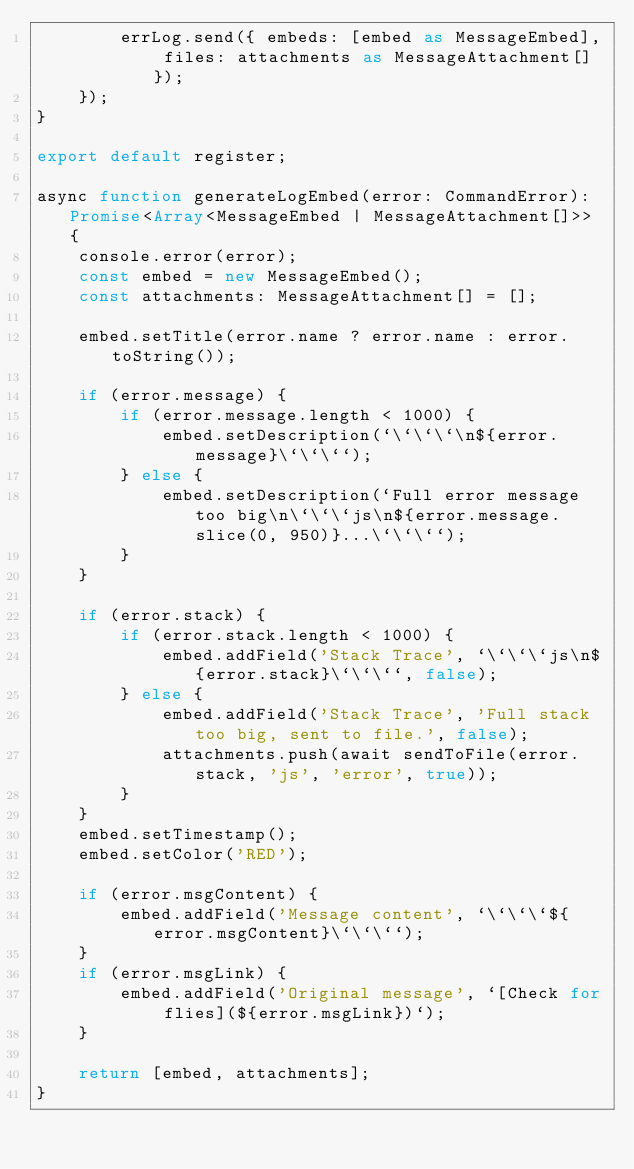<code> <loc_0><loc_0><loc_500><loc_500><_TypeScript_>		errLog.send({ embeds: [embed as MessageEmbed], files: attachments as MessageAttachment[] });
	});
}

export default register;

async function generateLogEmbed(error: CommandError): Promise<Array<MessageEmbed | MessageAttachment[]>> {
	console.error(error);
	const embed = new MessageEmbed();
	const attachments: MessageAttachment[] = [];

	embed.setTitle(error.name ? error.name : error.toString());

	if (error.message) {
		if (error.message.length < 1000) {
			embed.setDescription(`\`\`\`\n${error.message}\`\`\``);
		} else {
			embed.setDescription(`Full error message too big\n\`\`\`js\n${error.message.slice(0, 950)}...\`\`\``);
		}
	}

	if (error.stack) {
		if (error.stack.length < 1000) {
			embed.addField('Stack Trace', `\`\`\`js\n${error.stack}\`\`\``, false);
		} else {
			embed.addField('Stack Trace', 'Full stack too big, sent to file.', false);
			attachments.push(await sendToFile(error.stack, 'js', 'error', true));
		}
	}
	embed.setTimestamp();
	embed.setColor('RED');

	if (error.msgContent) {
		embed.addField('Message content', `\`\`\`${error.msgContent}\`\`\``);
	}
	if (error.msgLink) {
		embed.addField('Original message', `[Check for flies](${error.msgLink})`);
	}

	return [embed, attachments];
}
</code> 